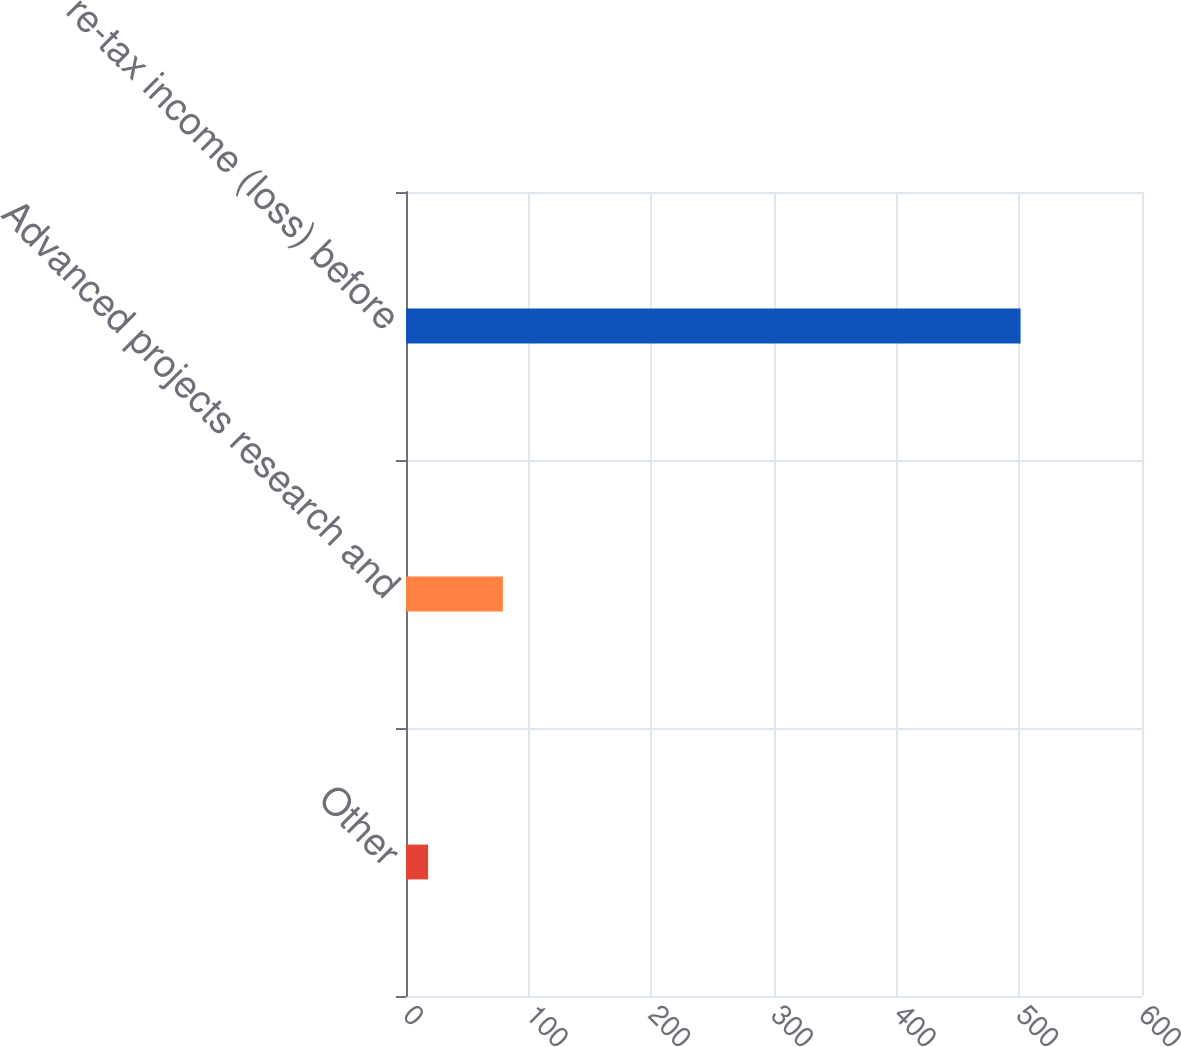Convert chart. <chart><loc_0><loc_0><loc_500><loc_500><bar_chart><fcel>Other<fcel>Advanced projects research and<fcel>Pre-tax income (loss) before<nl><fcel>18<fcel>79<fcel>501<nl></chart> 